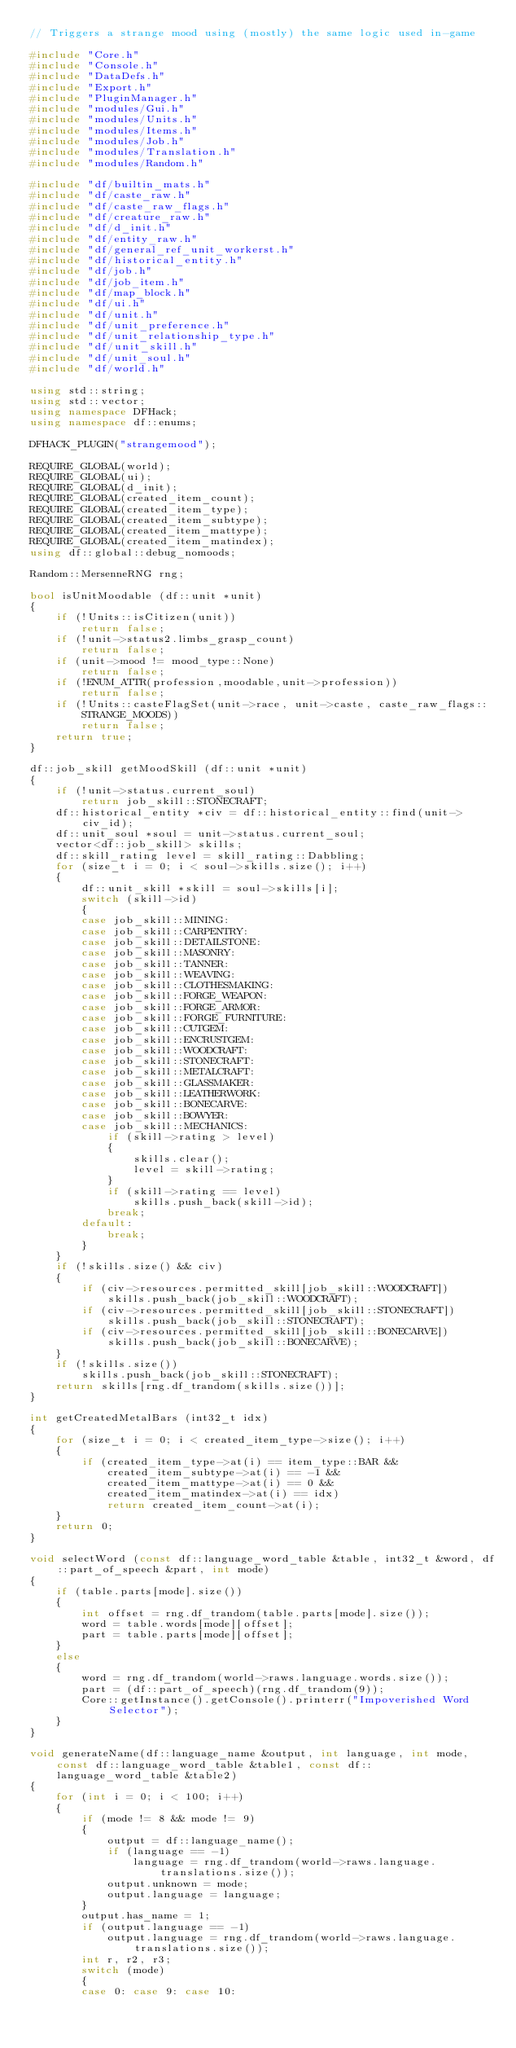<code> <loc_0><loc_0><loc_500><loc_500><_C++_>// Triggers a strange mood using (mostly) the same logic used in-game

#include "Core.h"
#include "Console.h"
#include "DataDefs.h"
#include "Export.h"
#include "PluginManager.h"
#include "modules/Gui.h"
#include "modules/Units.h"
#include "modules/Items.h"
#include "modules/Job.h"
#include "modules/Translation.h"
#include "modules/Random.h"

#include "df/builtin_mats.h"
#include "df/caste_raw.h"
#include "df/caste_raw_flags.h"
#include "df/creature_raw.h"
#include "df/d_init.h"
#include "df/entity_raw.h"
#include "df/general_ref_unit_workerst.h"
#include "df/historical_entity.h"
#include "df/job.h"
#include "df/job_item.h"
#include "df/map_block.h"
#include "df/ui.h"
#include "df/unit.h"
#include "df/unit_preference.h"
#include "df/unit_relationship_type.h"
#include "df/unit_skill.h"
#include "df/unit_soul.h"
#include "df/world.h"

using std::string;
using std::vector;
using namespace DFHack;
using namespace df::enums;

DFHACK_PLUGIN("strangemood");

REQUIRE_GLOBAL(world);
REQUIRE_GLOBAL(ui);
REQUIRE_GLOBAL(d_init);
REQUIRE_GLOBAL(created_item_count);
REQUIRE_GLOBAL(created_item_type);
REQUIRE_GLOBAL(created_item_subtype);
REQUIRE_GLOBAL(created_item_mattype);
REQUIRE_GLOBAL(created_item_matindex);
using df::global::debug_nomoods;

Random::MersenneRNG rng;

bool isUnitMoodable (df::unit *unit)
{
    if (!Units::isCitizen(unit))
        return false;
    if (!unit->status2.limbs_grasp_count)
        return false;
    if (unit->mood != mood_type::None)
        return false;
    if (!ENUM_ATTR(profession,moodable,unit->profession))
        return false;
    if (!Units::casteFlagSet(unit->race, unit->caste, caste_raw_flags::STRANGE_MOODS))
        return false;
    return true;
}

df::job_skill getMoodSkill (df::unit *unit)
{
    if (!unit->status.current_soul)
        return job_skill::STONECRAFT;
    df::historical_entity *civ = df::historical_entity::find(unit->civ_id);
    df::unit_soul *soul = unit->status.current_soul;
    vector<df::job_skill> skills;
    df::skill_rating level = skill_rating::Dabbling;
    for (size_t i = 0; i < soul->skills.size(); i++)
    {
        df::unit_skill *skill = soul->skills[i];
        switch (skill->id)
        {
        case job_skill::MINING:
        case job_skill::CARPENTRY:
        case job_skill::DETAILSTONE:
        case job_skill::MASONRY:
        case job_skill::TANNER:
        case job_skill::WEAVING:
        case job_skill::CLOTHESMAKING:
        case job_skill::FORGE_WEAPON:
        case job_skill::FORGE_ARMOR:
        case job_skill::FORGE_FURNITURE:
        case job_skill::CUTGEM:
        case job_skill::ENCRUSTGEM:
        case job_skill::WOODCRAFT:
        case job_skill::STONECRAFT:
        case job_skill::METALCRAFT:
        case job_skill::GLASSMAKER:
        case job_skill::LEATHERWORK:
        case job_skill::BONECARVE:
        case job_skill::BOWYER:
        case job_skill::MECHANICS:
            if (skill->rating > level)
            {
                skills.clear();
                level = skill->rating;
            }
            if (skill->rating == level)
                skills.push_back(skill->id);
            break;
        default:
            break;
        }
    }
    if (!skills.size() && civ)
    {
        if (civ->resources.permitted_skill[job_skill::WOODCRAFT])
            skills.push_back(job_skill::WOODCRAFT);
        if (civ->resources.permitted_skill[job_skill::STONECRAFT])
            skills.push_back(job_skill::STONECRAFT);
        if (civ->resources.permitted_skill[job_skill::BONECARVE])
            skills.push_back(job_skill::BONECARVE);
    }
    if (!skills.size())
        skills.push_back(job_skill::STONECRAFT);
    return skills[rng.df_trandom(skills.size())];
}

int getCreatedMetalBars (int32_t idx)
{
    for (size_t i = 0; i < created_item_type->size(); i++)
    {
        if (created_item_type->at(i) == item_type::BAR &&
            created_item_subtype->at(i) == -1 &&
            created_item_mattype->at(i) == 0 &&
            created_item_matindex->at(i) == idx)
            return created_item_count->at(i);
    }
    return 0;
}

void selectWord (const df::language_word_table &table, int32_t &word, df::part_of_speech &part, int mode)
{
    if (table.parts[mode].size())
    {
        int offset = rng.df_trandom(table.parts[mode].size());
        word = table.words[mode][offset];
        part = table.parts[mode][offset];
    }
    else
    {
        word = rng.df_trandom(world->raws.language.words.size());
        part = (df::part_of_speech)(rng.df_trandom(9));
        Core::getInstance().getConsole().printerr("Impoverished Word Selector");
    }
}

void generateName(df::language_name &output, int language, int mode, const df::language_word_table &table1, const df::language_word_table &table2)
{
    for (int i = 0; i < 100; i++)
    {
        if (mode != 8 && mode != 9)
        {
            output = df::language_name();
            if (language == -1)
                language = rng.df_trandom(world->raws.language.translations.size());
            output.unknown = mode;
            output.language = language;
        }
        output.has_name = 1;
        if (output.language == -1)
            output.language = rng.df_trandom(world->raws.language.translations.size());
        int r, r2, r3;
        switch (mode)
        {
        case 0: case 9: case 10:</code> 